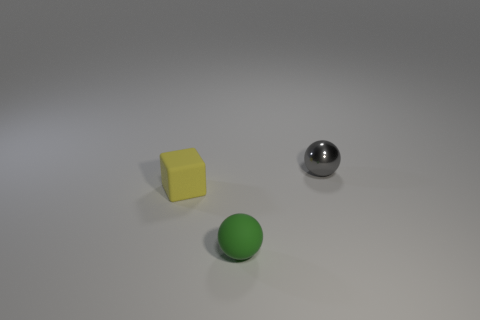Add 3 red matte balls. How many objects exist? 6 Subtract all cubes. How many objects are left? 2 Add 3 tiny yellow things. How many tiny yellow things are left? 4 Add 1 small green matte things. How many small green matte things exist? 2 Subtract 0 green cylinders. How many objects are left? 3 Subtract all cubes. Subtract all small cyan things. How many objects are left? 2 